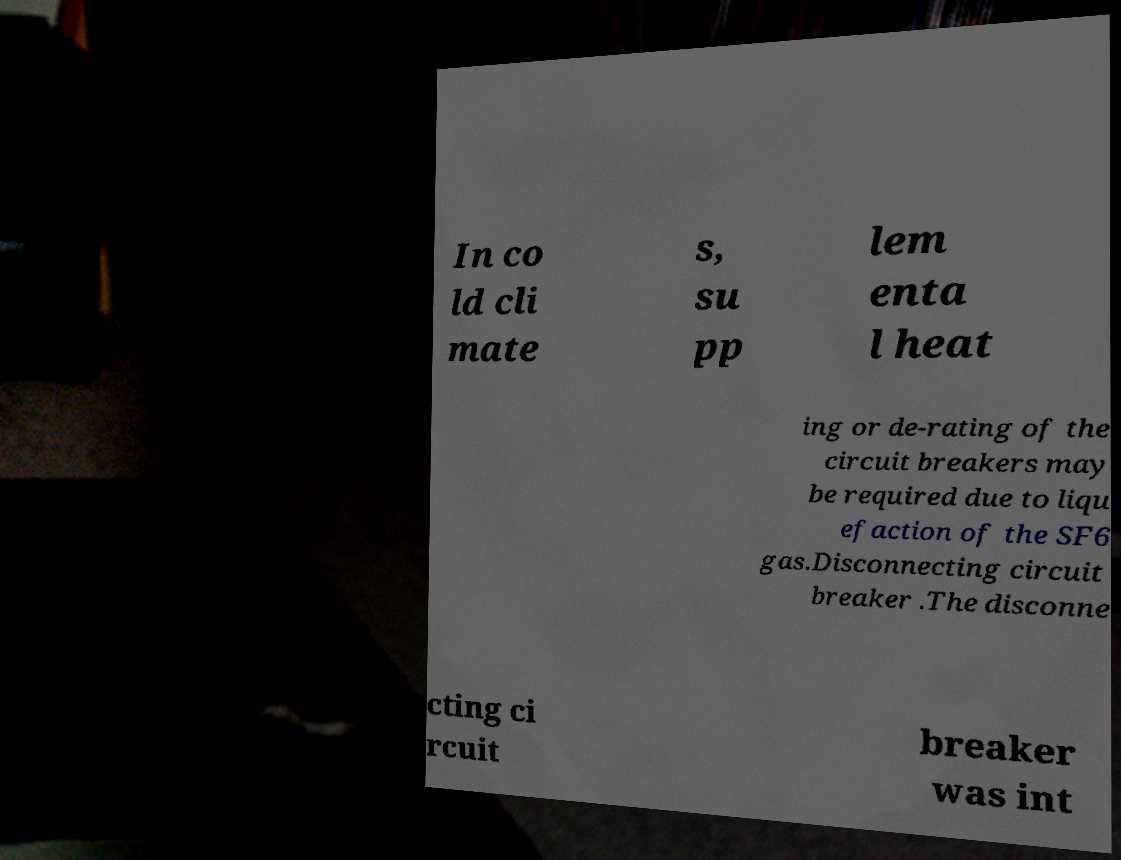Can you read and provide the text displayed in the image?This photo seems to have some interesting text. Can you extract and type it out for me? In co ld cli mate s, su pp lem enta l heat ing or de-rating of the circuit breakers may be required due to liqu efaction of the SF6 gas.Disconnecting circuit breaker .The disconne cting ci rcuit breaker was int 